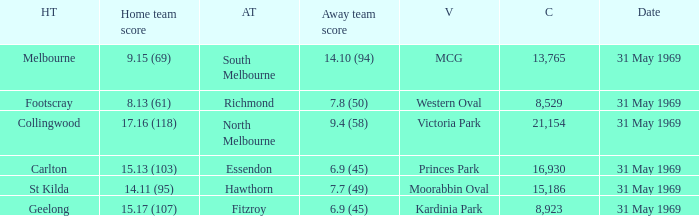Who was the home team that played in Victoria Park? Collingwood. 